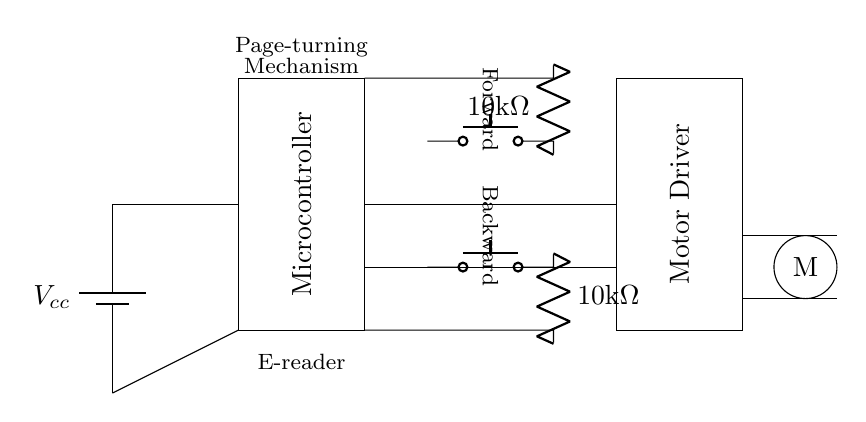What is the power supply voltage in the circuit? The power supply voltage is indicated by the label next to the battery symbol, which shows Vcc as the voltage supply.
Answer: Vcc How many tactile sensors are used in this circuit? By examining the diagram, there are two push buttons identified as tactile sensors: one for turning the page forward and another for backward.
Answer: Two What is the resistance value of the resistors in the circuit? The resistors connected to the tactile sensors are labeled as ten kilo ohms, indicating their resistance value.
Answer: 10kΩ What component is responsible for driving the motor? The motor driver block in the diagram is specifically labeled and indicates this component's function in driving the motor.
Answer: Motor Driver What is the function of the microcontroller in this circuit? The microcontroller processes signals from the tactile sensors and controls the motor driver to turn the pages, as implied by its placement and function label in the diagram.
Answer: Page-turning Which components are directly connected to the power supply? The power supply is connected to both the microcontroller and the motor driver in the circuit as shown by the direct lines from the voltage source.
Answer: Microcontroller, Motor Driver How does the tactile sensor for the forward action connect to the microcontroller? The forward tactile sensor is connected through the push button and resistor, then leads to the microcontroller, as shown by the lines depicting the connections in the circuit.
Answer: Push button, resistor, microcontroller 